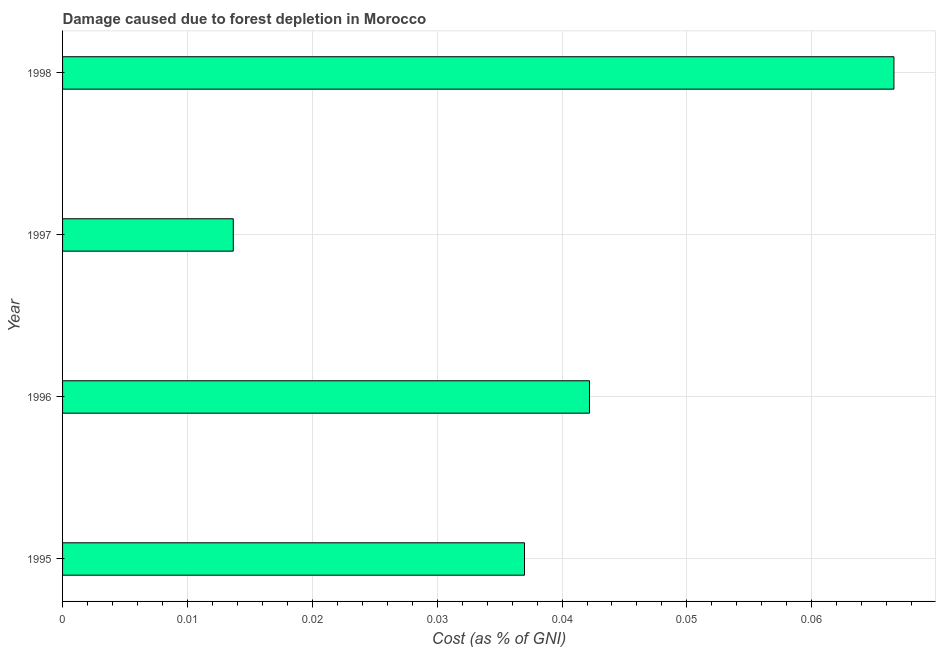Does the graph contain any zero values?
Provide a succinct answer. No. Does the graph contain grids?
Provide a succinct answer. Yes. What is the title of the graph?
Your answer should be very brief. Damage caused due to forest depletion in Morocco. What is the label or title of the X-axis?
Give a very brief answer. Cost (as % of GNI). What is the label or title of the Y-axis?
Keep it short and to the point. Year. What is the damage caused due to forest depletion in 1995?
Offer a very short reply. 0.04. Across all years, what is the maximum damage caused due to forest depletion?
Ensure brevity in your answer.  0.07. Across all years, what is the minimum damage caused due to forest depletion?
Your response must be concise. 0.01. In which year was the damage caused due to forest depletion minimum?
Provide a succinct answer. 1997. What is the sum of the damage caused due to forest depletion?
Give a very brief answer. 0.16. What is the difference between the damage caused due to forest depletion in 1995 and 1998?
Offer a very short reply. -0.03. What is the average damage caused due to forest depletion per year?
Provide a succinct answer. 0.04. What is the median damage caused due to forest depletion?
Keep it short and to the point. 0.04. In how many years, is the damage caused due to forest depletion greater than 0.046 %?
Give a very brief answer. 1. What is the ratio of the damage caused due to forest depletion in 1995 to that in 1998?
Ensure brevity in your answer.  0.56. Is the damage caused due to forest depletion in 1995 less than that in 1998?
Give a very brief answer. Yes. What is the difference between the highest and the second highest damage caused due to forest depletion?
Offer a very short reply. 0.02. What is the difference between the highest and the lowest damage caused due to forest depletion?
Ensure brevity in your answer.  0.05. In how many years, is the damage caused due to forest depletion greater than the average damage caused due to forest depletion taken over all years?
Provide a succinct answer. 2. How many bars are there?
Keep it short and to the point. 4. Are all the bars in the graph horizontal?
Make the answer very short. Yes. What is the difference between two consecutive major ticks on the X-axis?
Give a very brief answer. 0.01. Are the values on the major ticks of X-axis written in scientific E-notation?
Provide a succinct answer. No. What is the Cost (as % of GNI) in 1995?
Your answer should be very brief. 0.04. What is the Cost (as % of GNI) of 1996?
Your response must be concise. 0.04. What is the Cost (as % of GNI) in 1997?
Give a very brief answer. 0.01. What is the Cost (as % of GNI) in 1998?
Offer a terse response. 0.07. What is the difference between the Cost (as % of GNI) in 1995 and 1996?
Your answer should be compact. -0.01. What is the difference between the Cost (as % of GNI) in 1995 and 1997?
Your answer should be very brief. 0.02. What is the difference between the Cost (as % of GNI) in 1995 and 1998?
Provide a short and direct response. -0.03. What is the difference between the Cost (as % of GNI) in 1996 and 1997?
Your response must be concise. 0.03. What is the difference between the Cost (as % of GNI) in 1996 and 1998?
Keep it short and to the point. -0.02. What is the difference between the Cost (as % of GNI) in 1997 and 1998?
Ensure brevity in your answer.  -0.05. What is the ratio of the Cost (as % of GNI) in 1995 to that in 1996?
Your answer should be compact. 0.88. What is the ratio of the Cost (as % of GNI) in 1995 to that in 1997?
Offer a terse response. 2.71. What is the ratio of the Cost (as % of GNI) in 1995 to that in 1998?
Your answer should be very brief. 0.56. What is the ratio of the Cost (as % of GNI) in 1996 to that in 1997?
Your answer should be compact. 3.09. What is the ratio of the Cost (as % of GNI) in 1996 to that in 1998?
Your response must be concise. 0.63. What is the ratio of the Cost (as % of GNI) in 1997 to that in 1998?
Give a very brief answer. 0.2. 